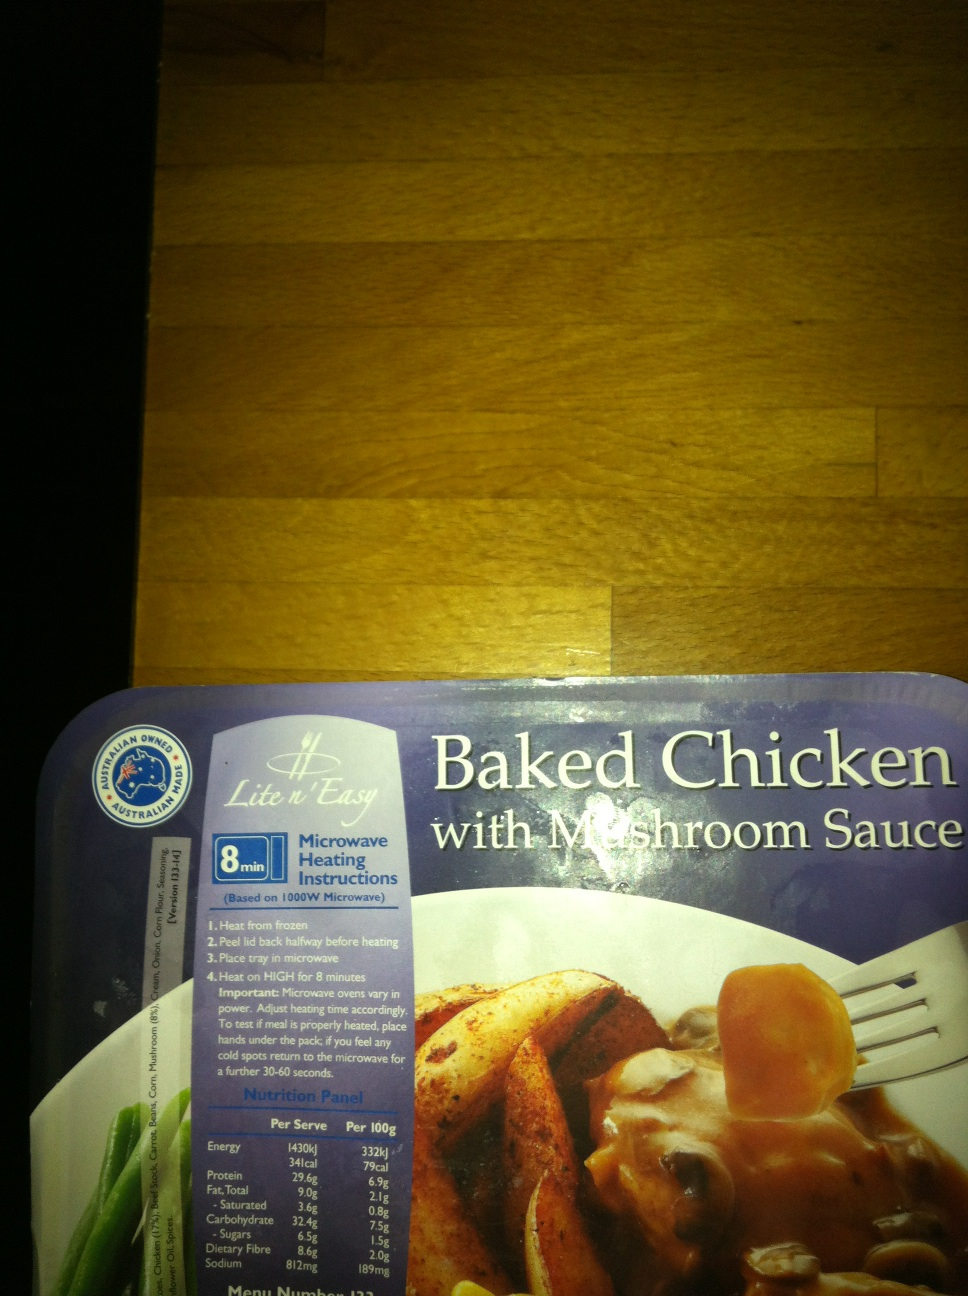Is this product suitable for specific dietary requirements? The meal primarily caters to individuals looking for quick meal solutions without specific dietary restrictions indicated on the packaging. However, it may not be suitable for those on low sodium or low fat diets due to its sodium and fat content. Always check ingredient lists for potential allergens or dietary conflicts. 